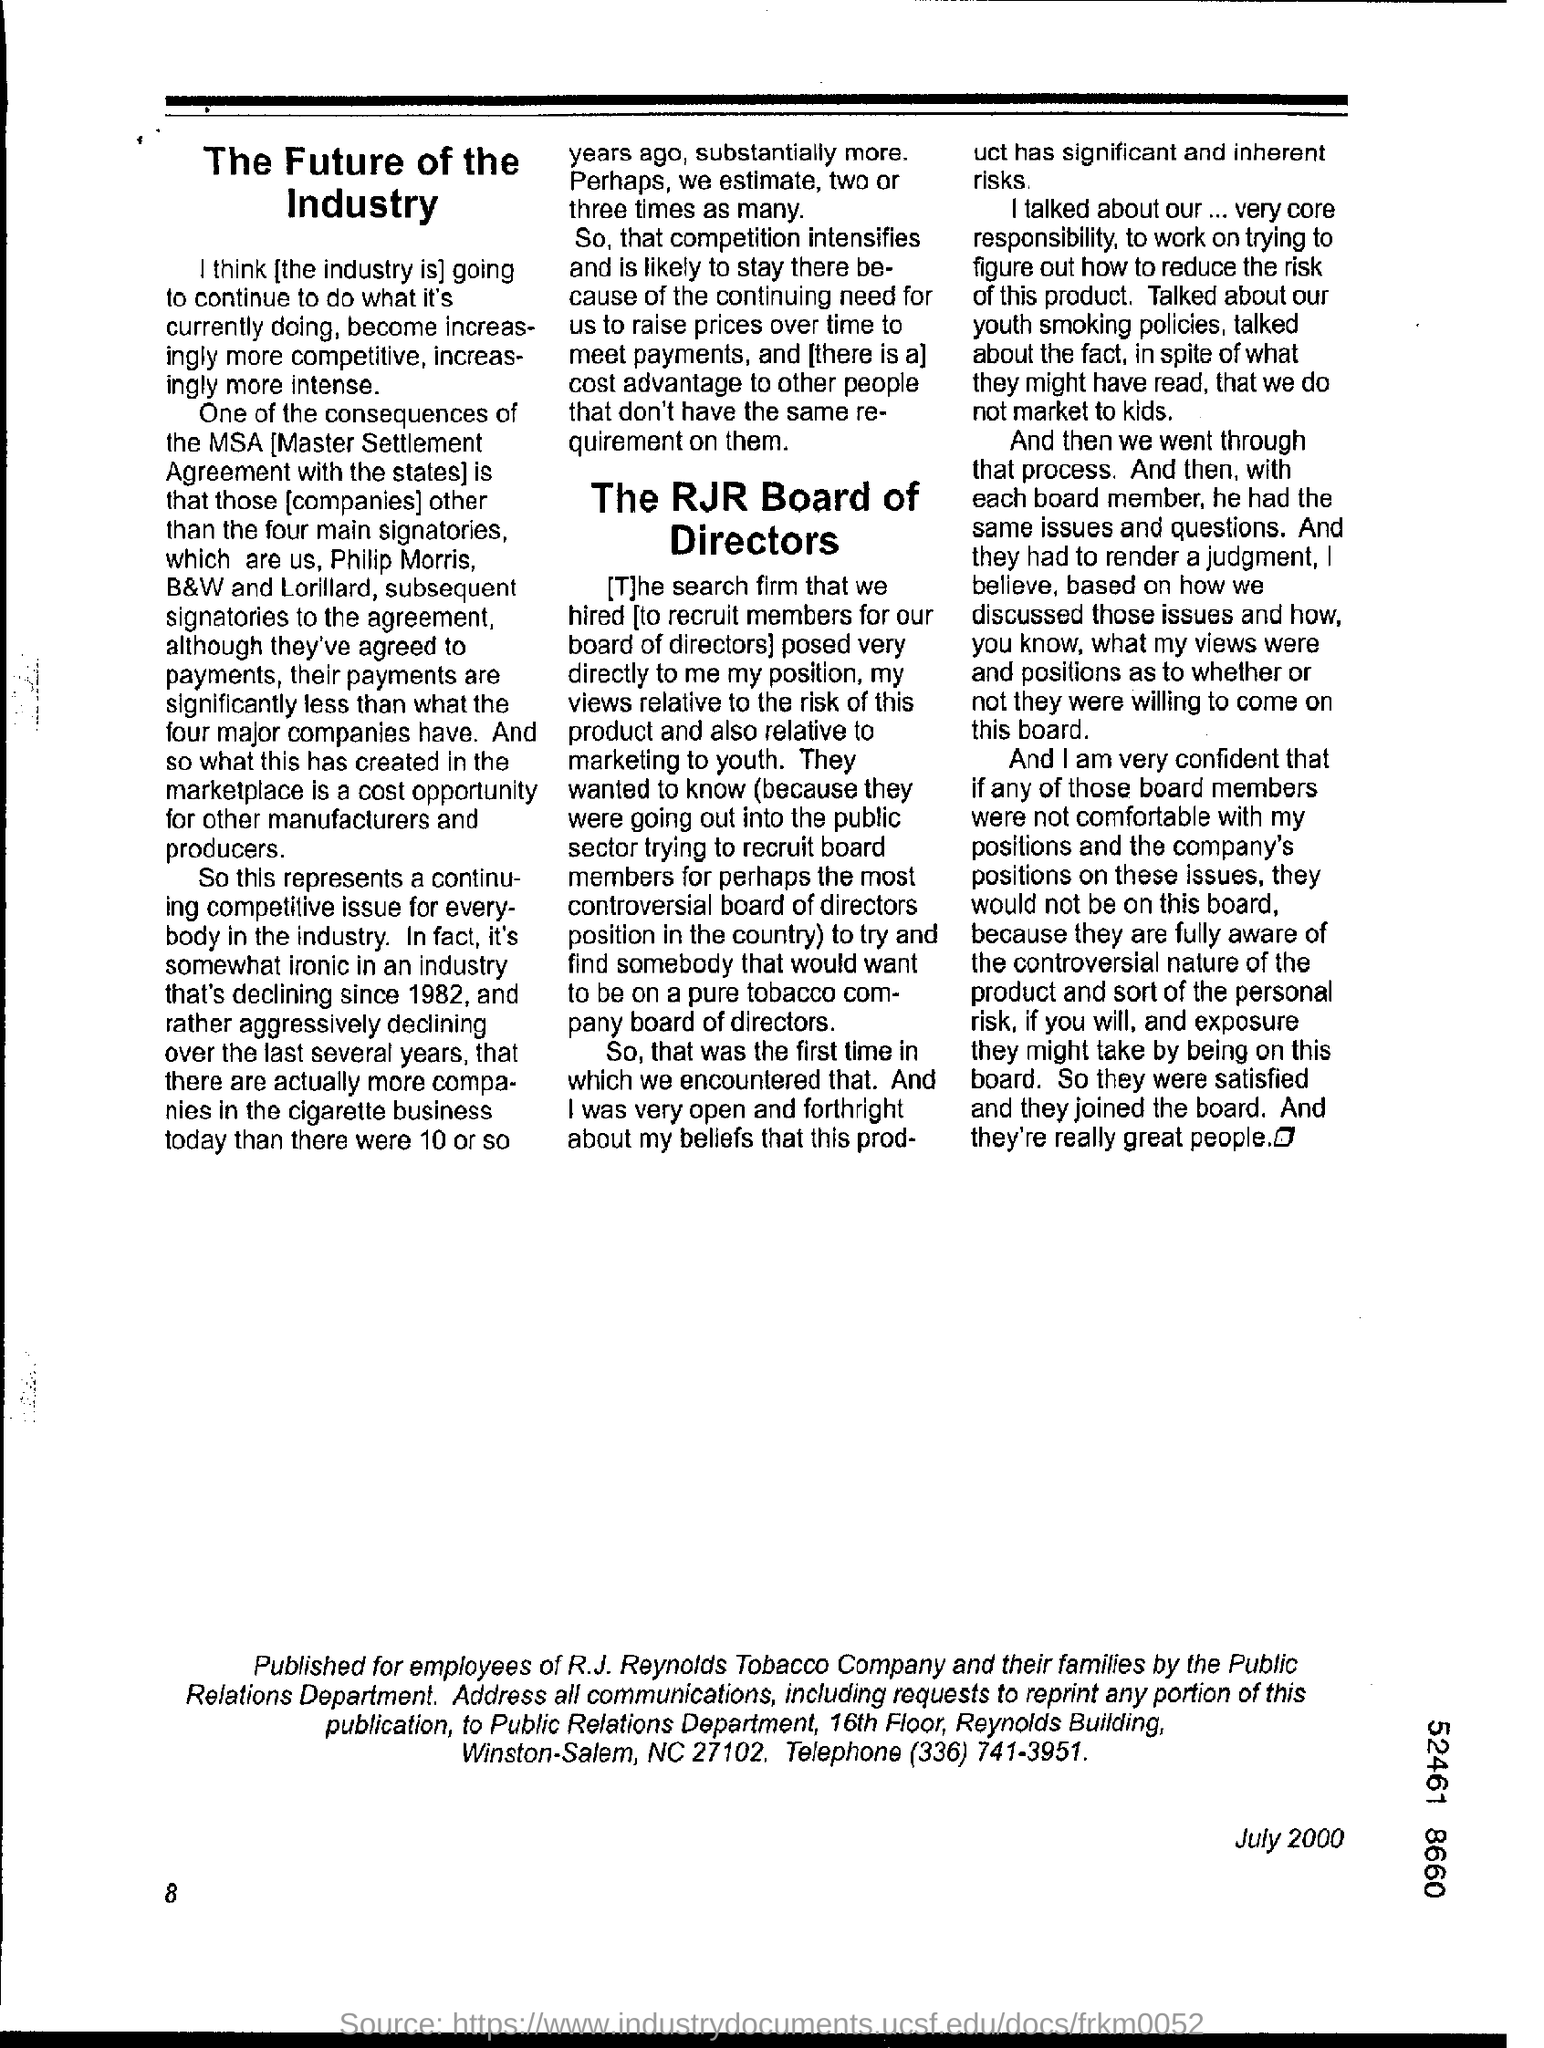Specify some key components in this picture. The date mentioned in this document is JULY 2000. The page number mentioned in this document is 8. 